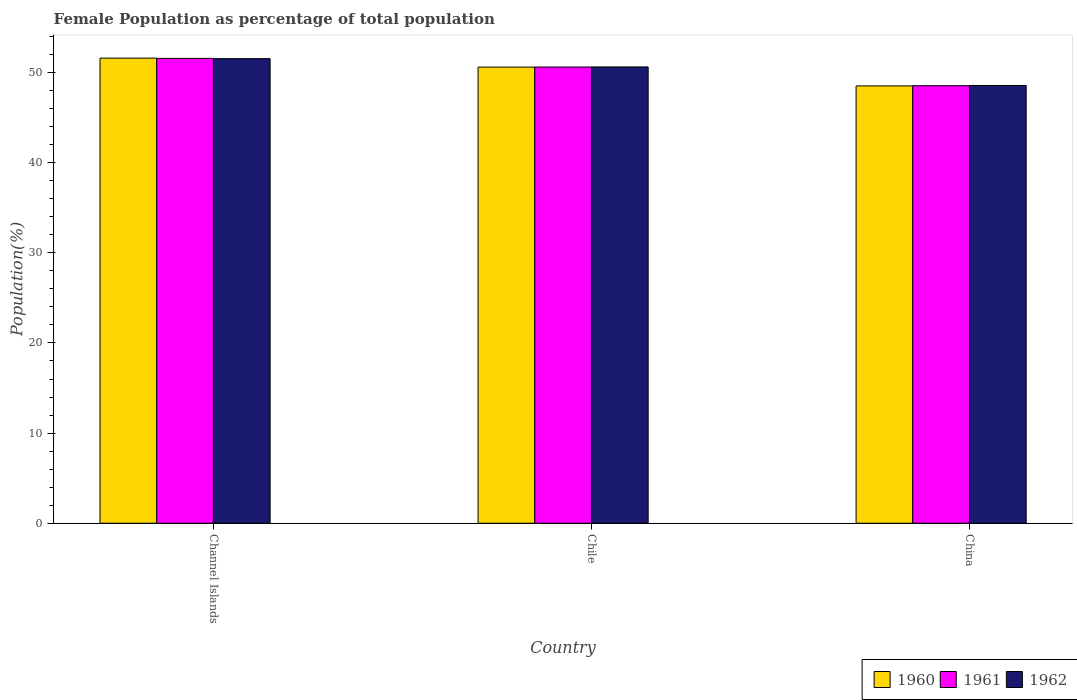How many different coloured bars are there?
Your answer should be compact. 3. How many groups of bars are there?
Offer a very short reply. 3. Are the number of bars per tick equal to the number of legend labels?
Your answer should be compact. Yes. What is the label of the 3rd group of bars from the left?
Ensure brevity in your answer.  China. In how many cases, is the number of bars for a given country not equal to the number of legend labels?
Keep it short and to the point. 0. What is the female population in in 1962 in Channel Islands?
Your answer should be very brief. 51.54. Across all countries, what is the maximum female population in in 1961?
Provide a succinct answer. 51.57. Across all countries, what is the minimum female population in in 1960?
Provide a short and direct response. 48.52. In which country was the female population in in 1962 maximum?
Keep it short and to the point. Channel Islands. In which country was the female population in in 1962 minimum?
Provide a succinct answer. China. What is the total female population in in 1961 in the graph?
Your answer should be compact. 150.73. What is the difference between the female population in in 1962 in Chile and that in China?
Offer a very short reply. 2.06. What is the difference between the female population in in 1962 in China and the female population in in 1960 in Channel Islands?
Your answer should be compact. -3.03. What is the average female population in in 1962 per country?
Your answer should be compact. 50.24. What is the difference between the female population in of/in 1961 and female population in of/in 1960 in Channel Islands?
Keep it short and to the point. -0.03. In how many countries, is the female population in in 1960 greater than 24 %?
Your response must be concise. 3. What is the ratio of the female population in in 1961 in Chile to that in China?
Your answer should be very brief. 1.04. What is the difference between the highest and the second highest female population in in 1962?
Give a very brief answer. -2.06. What is the difference between the highest and the lowest female population in in 1960?
Your response must be concise. 3.08. Is the sum of the female population in in 1961 in Chile and China greater than the maximum female population in in 1962 across all countries?
Give a very brief answer. Yes. What does the 1st bar from the right in Channel Islands represents?
Your answer should be compact. 1962. Is it the case that in every country, the sum of the female population in in 1960 and female population in in 1962 is greater than the female population in in 1961?
Provide a short and direct response. Yes. How many bars are there?
Ensure brevity in your answer.  9. Are all the bars in the graph horizontal?
Keep it short and to the point. No. Does the graph contain grids?
Offer a terse response. No. Where does the legend appear in the graph?
Your response must be concise. Bottom right. How are the legend labels stacked?
Your answer should be compact. Horizontal. What is the title of the graph?
Keep it short and to the point. Female Population as percentage of total population. Does "1977" appear as one of the legend labels in the graph?
Keep it short and to the point. No. What is the label or title of the Y-axis?
Give a very brief answer. Population(%). What is the Population(%) in 1960 in Channel Islands?
Your response must be concise. 51.6. What is the Population(%) of 1961 in Channel Islands?
Ensure brevity in your answer.  51.57. What is the Population(%) of 1962 in Channel Islands?
Ensure brevity in your answer.  51.54. What is the Population(%) in 1960 in Chile?
Your response must be concise. 50.61. What is the Population(%) of 1961 in Chile?
Provide a succinct answer. 50.61. What is the Population(%) in 1962 in Chile?
Make the answer very short. 50.62. What is the Population(%) in 1960 in China?
Your response must be concise. 48.52. What is the Population(%) of 1961 in China?
Your answer should be compact. 48.54. What is the Population(%) of 1962 in China?
Make the answer very short. 48.57. Across all countries, what is the maximum Population(%) in 1960?
Your answer should be compact. 51.6. Across all countries, what is the maximum Population(%) of 1961?
Provide a succinct answer. 51.57. Across all countries, what is the maximum Population(%) of 1962?
Offer a very short reply. 51.54. Across all countries, what is the minimum Population(%) of 1960?
Offer a very short reply. 48.52. Across all countries, what is the minimum Population(%) in 1961?
Provide a succinct answer. 48.54. Across all countries, what is the minimum Population(%) of 1962?
Your answer should be very brief. 48.57. What is the total Population(%) of 1960 in the graph?
Give a very brief answer. 150.72. What is the total Population(%) of 1961 in the graph?
Offer a terse response. 150.73. What is the total Population(%) of 1962 in the graph?
Offer a terse response. 150.73. What is the difference between the Population(%) of 1961 in Channel Islands and that in Chile?
Offer a very short reply. 0.96. What is the difference between the Population(%) of 1962 in Channel Islands and that in Chile?
Make the answer very short. 0.92. What is the difference between the Population(%) of 1960 in Channel Islands and that in China?
Offer a terse response. 3.08. What is the difference between the Population(%) of 1961 in Channel Islands and that in China?
Make the answer very short. 3.03. What is the difference between the Population(%) in 1962 in Channel Islands and that in China?
Your answer should be very brief. 2.98. What is the difference between the Population(%) in 1960 in Chile and that in China?
Provide a succinct answer. 2.09. What is the difference between the Population(%) of 1961 in Chile and that in China?
Offer a terse response. 2.07. What is the difference between the Population(%) of 1962 in Chile and that in China?
Keep it short and to the point. 2.06. What is the difference between the Population(%) in 1960 in Channel Islands and the Population(%) in 1961 in Chile?
Provide a succinct answer. 0.99. What is the difference between the Population(%) in 1960 in Channel Islands and the Population(%) in 1962 in Chile?
Make the answer very short. 0.98. What is the difference between the Population(%) of 1960 in Channel Islands and the Population(%) of 1961 in China?
Give a very brief answer. 3.06. What is the difference between the Population(%) in 1960 in Channel Islands and the Population(%) in 1962 in China?
Your answer should be compact. 3.03. What is the difference between the Population(%) of 1961 in Channel Islands and the Population(%) of 1962 in China?
Provide a succinct answer. 3. What is the difference between the Population(%) of 1960 in Chile and the Population(%) of 1961 in China?
Provide a short and direct response. 2.06. What is the difference between the Population(%) in 1960 in Chile and the Population(%) in 1962 in China?
Offer a very short reply. 2.04. What is the difference between the Population(%) of 1961 in Chile and the Population(%) of 1962 in China?
Make the answer very short. 2.05. What is the average Population(%) of 1960 per country?
Your answer should be very brief. 50.24. What is the average Population(%) of 1961 per country?
Your answer should be compact. 50.24. What is the average Population(%) of 1962 per country?
Provide a succinct answer. 50.24. What is the difference between the Population(%) of 1960 and Population(%) of 1961 in Channel Islands?
Make the answer very short. 0.03. What is the difference between the Population(%) in 1960 and Population(%) in 1962 in Channel Islands?
Your response must be concise. 0.06. What is the difference between the Population(%) in 1961 and Population(%) in 1962 in Channel Islands?
Keep it short and to the point. 0.03. What is the difference between the Population(%) in 1960 and Population(%) in 1961 in Chile?
Your answer should be very brief. -0.01. What is the difference between the Population(%) of 1960 and Population(%) of 1962 in Chile?
Give a very brief answer. -0.02. What is the difference between the Population(%) of 1961 and Population(%) of 1962 in Chile?
Offer a very short reply. -0.01. What is the difference between the Population(%) in 1960 and Population(%) in 1961 in China?
Ensure brevity in your answer.  -0.03. What is the difference between the Population(%) of 1960 and Population(%) of 1962 in China?
Your response must be concise. -0.05. What is the difference between the Population(%) in 1961 and Population(%) in 1962 in China?
Offer a very short reply. -0.02. What is the ratio of the Population(%) in 1960 in Channel Islands to that in Chile?
Keep it short and to the point. 1.02. What is the ratio of the Population(%) of 1961 in Channel Islands to that in Chile?
Offer a terse response. 1.02. What is the ratio of the Population(%) in 1962 in Channel Islands to that in Chile?
Your answer should be very brief. 1.02. What is the ratio of the Population(%) in 1960 in Channel Islands to that in China?
Offer a terse response. 1.06. What is the ratio of the Population(%) in 1961 in Channel Islands to that in China?
Offer a terse response. 1.06. What is the ratio of the Population(%) of 1962 in Channel Islands to that in China?
Offer a terse response. 1.06. What is the ratio of the Population(%) in 1960 in Chile to that in China?
Provide a short and direct response. 1.04. What is the ratio of the Population(%) of 1961 in Chile to that in China?
Provide a short and direct response. 1.04. What is the ratio of the Population(%) in 1962 in Chile to that in China?
Your answer should be compact. 1.04. What is the difference between the highest and the second highest Population(%) in 1960?
Keep it short and to the point. 1. What is the difference between the highest and the second highest Population(%) in 1961?
Make the answer very short. 0.96. What is the difference between the highest and the second highest Population(%) in 1962?
Offer a terse response. 0.92. What is the difference between the highest and the lowest Population(%) of 1960?
Give a very brief answer. 3.08. What is the difference between the highest and the lowest Population(%) in 1961?
Offer a very short reply. 3.03. What is the difference between the highest and the lowest Population(%) in 1962?
Provide a short and direct response. 2.98. 